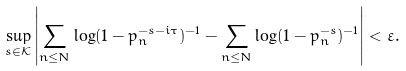Convert formula to latex. <formula><loc_0><loc_0><loc_500><loc_500>\sup _ { s \in { \mathcal { K } } } \left | \sum _ { n \leq N } \log ( 1 - p _ { n } ^ { - s - i \tau } ) ^ { - 1 } - \sum _ { n \leq N } \log ( 1 - p _ { n } ^ { - s } ) ^ { - 1 } \right | < \varepsilon .</formula> 